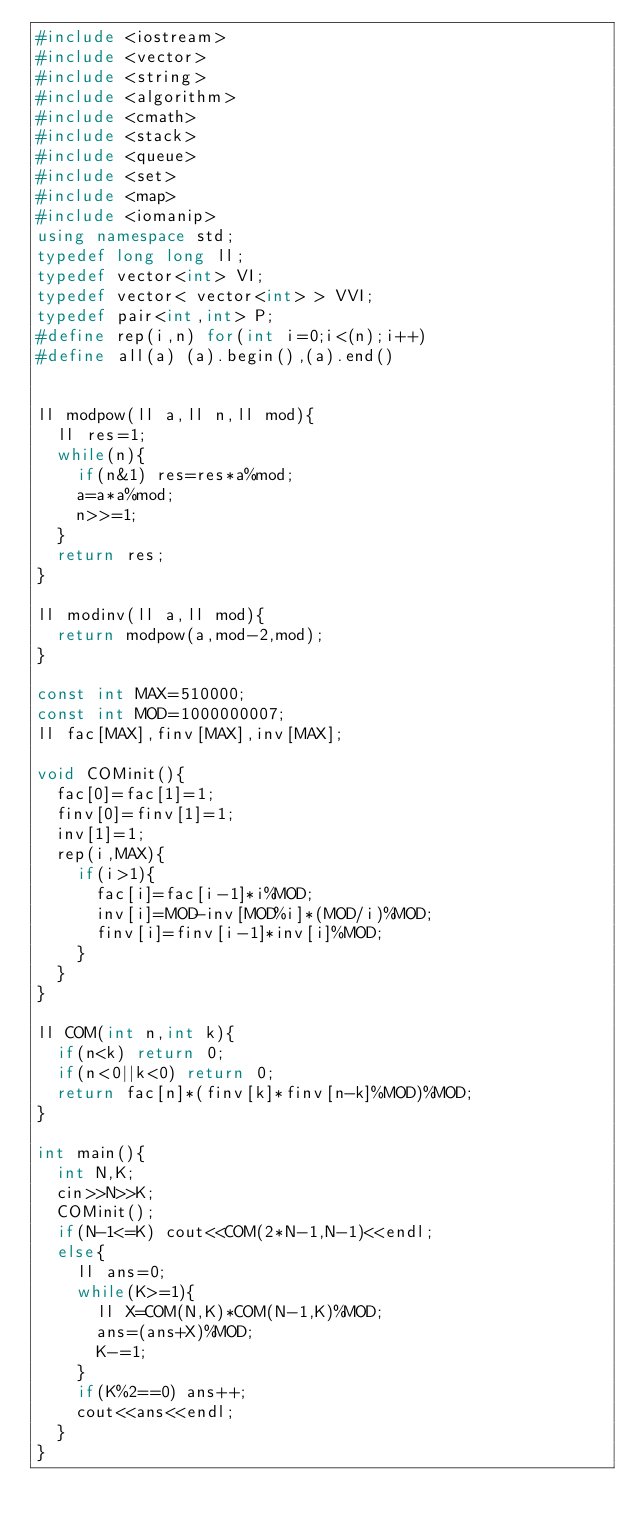<code> <loc_0><loc_0><loc_500><loc_500><_C++_>#include <iostream>
#include <vector>
#include <string>
#include <algorithm>
#include <cmath>
#include <stack>
#include <queue>
#include <set>
#include <map>
#include <iomanip>
using namespace std;
typedef long long ll;
typedef vector<int> VI;
typedef vector< vector<int> > VVI;
typedef pair<int,int> P;
#define rep(i,n) for(int i=0;i<(n);i++)
#define all(a) (a).begin(),(a).end()


ll modpow(ll a,ll n,ll mod){
  ll res=1;
  while(n){
    if(n&1) res=res*a%mod;
    a=a*a%mod;
    n>>=1;
  }
  return res;
}

ll modinv(ll a,ll mod){
  return modpow(a,mod-2,mod);
}

const int MAX=510000;
const int MOD=1000000007;
ll fac[MAX],finv[MAX],inv[MAX];

void COMinit(){
  fac[0]=fac[1]=1;
  finv[0]=finv[1]=1;
  inv[1]=1;
  rep(i,MAX){
    if(i>1){
      fac[i]=fac[i-1]*i%MOD;
      inv[i]=MOD-inv[MOD%i]*(MOD/i)%MOD;
      finv[i]=finv[i-1]*inv[i]%MOD;
    }
  }
}

ll COM(int n,int k){
  if(n<k) return 0;
  if(n<0||k<0) return 0;
  return fac[n]*(finv[k]*finv[n-k]%MOD)%MOD;
}
 
int main(){
  int N,K;
  cin>>N>>K;
  COMinit();
  if(N-1<=K) cout<<COM(2*N-1,N-1)<<endl;
  else{
    ll ans=0;
    while(K>=1){
      ll X=COM(N,K)*COM(N-1,K)%MOD;
      ans=(ans+X)%MOD;
      K-=1;
    }
    if(K%2==0) ans++;
    cout<<ans<<endl;
  }
}</code> 